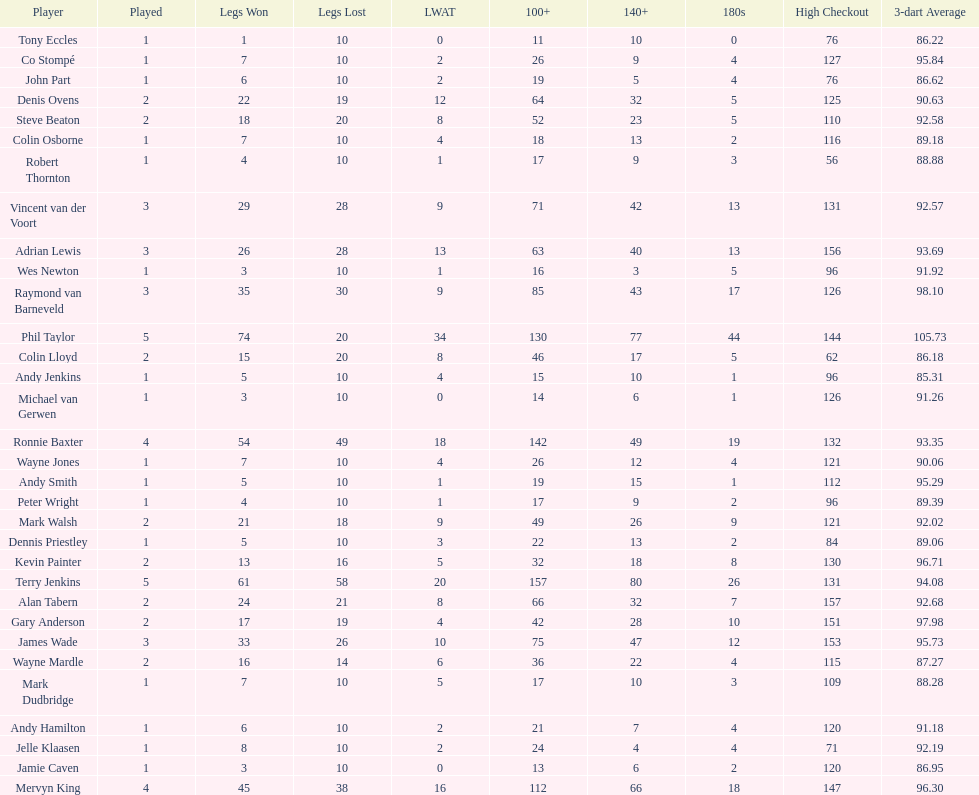How many players have taken part in more than three games in total? 4. Could you help me parse every detail presented in this table? {'header': ['Player', 'Played', 'Legs Won', 'Legs Lost', 'LWAT', '100+', '140+', '180s', 'High Checkout', '3-dart Average'], 'rows': [['Tony Eccles', '1', '1', '10', '0', '11', '10', '0', '76', '86.22'], ['Co Stompé', '1', '7', '10', '2', '26', '9', '4', '127', '95.84'], ['John Part', '1', '6', '10', '2', '19', '5', '4', '76', '86.62'], ['Denis Ovens', '2', '22', '19', '12', '64', '32', '5', '125', '90.63'], ['Steve Beaton', '2', '18', '20', '8', '52', '23', '5', '110', '92.58'], ['Colin Osborne', '1', '7', '10', '4', '18', '13', '2', '116', '89.18'], ['Robert Thornton', '1', '4', '10', '1', '17', '9', '3', '56', '88.88'], ['Vincent van der Voort', '3', '29', '28', '9', '71', '42', '13', '131', '92.57'], ['Adrian Lewis', '3', '26', '28', '13', '63', '40', '13', '156', '93.69'], ['Wes Newton', '1', '3', '10', '1', '16', '3', '5', '96', '91.92'], ['Raymond van Barneveld', '3', '35', '30', '9', '85', '43', '17', '126', '98.10'], ['Phil Taylor', '5', '74', '20', '34', '130', '77', '44', '144', '105.73'], ['Colin Lloyd', '2', '15', '20', '8', '46', '17', '5', '62', '86.18'], ['Andy Jenkins', '1', '5', '10', '4', '15', '10', '1', '96', '85.31'], ['Michael van Gerwen', '1', '3', '10', '0', '14', '6', '1', '126', '91.26'], ['Ronnie Baxter', '4', '54', '49', '18', '142', '49', '19', '132', '93.35'], ['Wayne Jones', '1', '7', '10', '4', '26', '12', '4', '121', '90.06'], ['Andy Smith', '1', '5', '10', '1', '19', '15', '1', '112', '95.29'], ['Peter Wright', '1', '4', '10', '1', '17', '9', '2', '96', '89.39'], ['Mark Walsh', '2', '21', '18', '9', '49', '26', '9', '121', '92.02'], ['Dennis Priestley', '1', '5', '10', '3', '22', '13', '2', '84', '89.06'], ['Kevin Painter', '2', '13', '16', '5', '32', '18', '8', '130', '96.71'], ['Terry Jenkins', '5', '61', '58', '20', '157', '80', '26', '131', '94.08'], ['Alan Tabern', '2', '24', '21', '8', '66', '32', '7', '157', '92.68'], ['Gary Anderson', '2', '17', '19', '4', '42', '28', '10', '151', '97.98'], ['James Wade', '3', '33', '26', '10', '75', '47', '12', '153', '95.73'], ['Wayne Mardle', '2', '16', '14', '6', '36', '22', '4', '115', '87.27'], ['Mark Dudbridge', '1', '7', '10', '5', '17', '10', '3', '109', '88.28'], ['Andy Hamilton', '1', '6', '10', '2', '21', '7', '4', '120', '91.18'], ['Jelle Klaasen', '1', '8', '10', '2', '24', '4', '4', '71', '92.19'], ['Jamie Caven', '1', '3', '10', '0', '13', '6', '2', '120', '86.95'], ['Mervyn King', '4', '45', '38', '16', '112', '66', '18', '147', '96.30']]} 